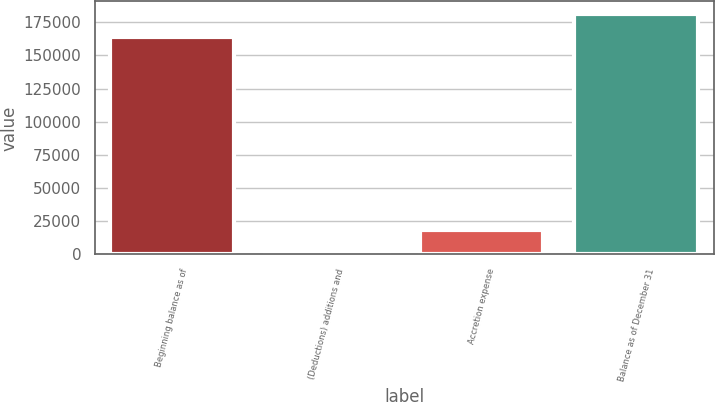Convert chart to OTSL. <chart><loc_0><loc_0><loc_500><loc_500><bar_chart><fcel>Beginning balance as of<fcel>(Deductions) additions and<fcel>Accretion expense<fcel>Balance as of December 31<nl><fcel>164222<fcel>710<fcel>18137<fcel>181649<nl></chart> 